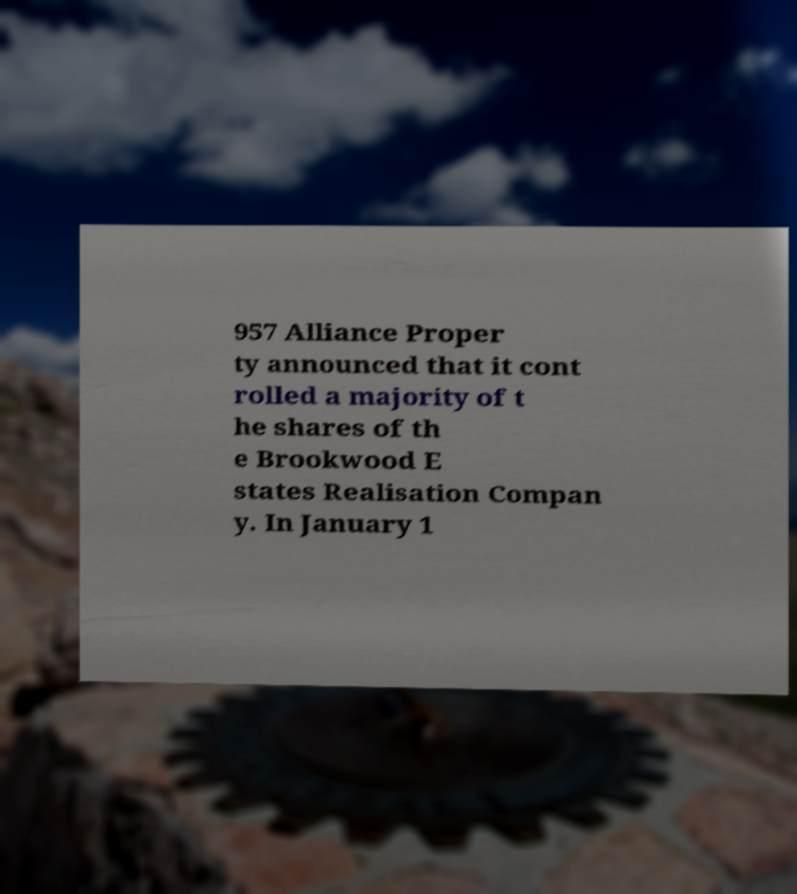Can you accurately transcribe the text from the provided image for me? 957 Alliance Proper ty announced that it cont rolled a majority of t he shares of th e Brookwood E states Realisation Compan y. In January 1 